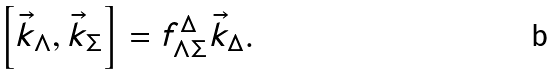Convert formula to latex. <formula><loc_0><loc_0><loc_500><loc_500>\left [ \vec { k } _ { \Lambda } , \vec { k } _ { \Sigma } \right ] = f ^ { \Delta } _ { \Lambda \Sigma } \vec { k } _ { \Delta } .</formula> 